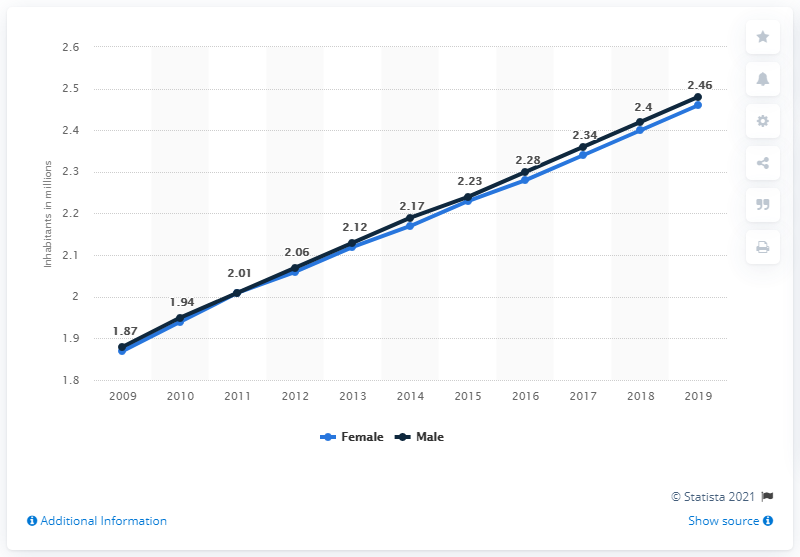List a handful of essential elements in this visual. In 2019, the male population of Liberia was 2.46 million. In 2019, the female population of Liberia was 2.46 million. 